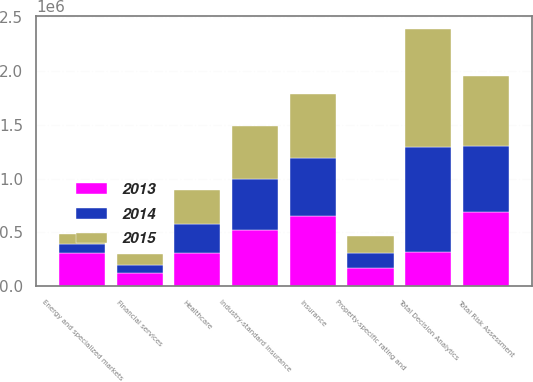<chart> <loc_0><loc_0><loc_500><loc_500><stacked_bar_chart><ecel><fcel>Insurance<fcel>Financial services<fcel>Healthcare<fcel>Energy and specialized markets<fcel>Total Decision Analytics<fcel>Industry-standard insurance<fcel>Property-specific rating and<fcel>Total Risk Assessment<nl><fcel>2013<fcel>647161<fcel>116556<fcel>307291<fcel>308811<fcel>315628<fcel>524606<fcel>163585<fcel>688191<nl><fcel>2015<fcel>598757<fcel>96763<fcel>315628<fcel>84926<fcel>1.09607e+06<fcel>495065<fcel>155587<fcel>650652<nl><fcel>2014<fcel>539150<fcel>81113<fcel>271538<fcel>85626<fcel>977427<fcel>471130<fcel>147146<fcel>618276<nl></chart> 